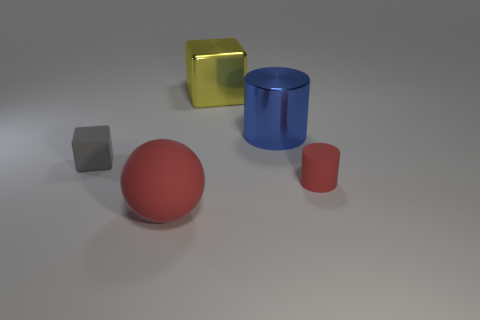Subtract all yellow cylinders. Subtract all red spheres. How many cylinders are left? 2 Add 3 large blue cylinders. How many objects exist? 8 Subtract all balls. How many objects are left? 4 Add 3 tiny red cylinders. How many tiny red cylinders exist? 4 Subtract 0 brown blocks. How many objects are left? 5 Subtract all gray cylinders. Subtract all large blue shiny cylinders. How many objects are left? 4 Add 1 yellow objects. How many yellow objects are left? 2 